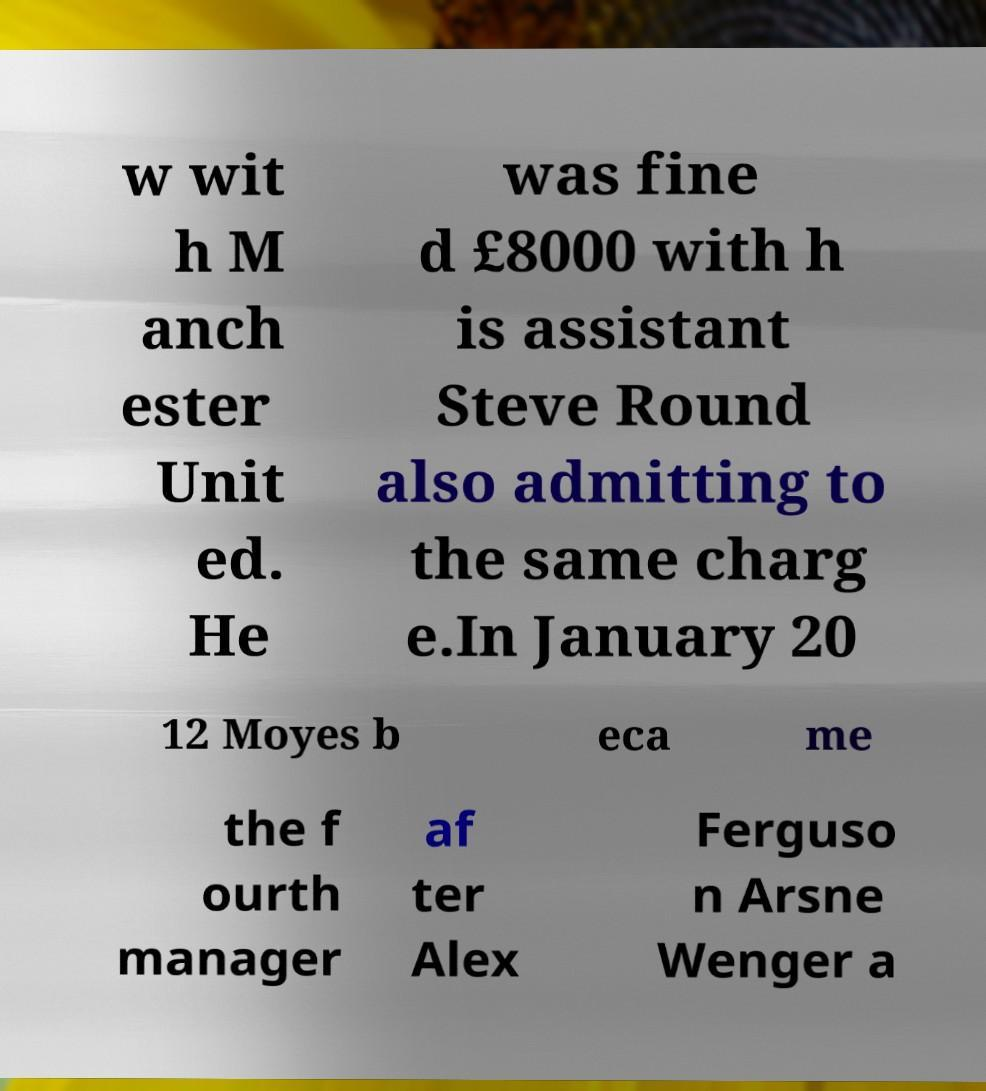Can you read and provide the text displayed in the image?This photo seems to have some interesting text. Can you extract and type it out for me? w wit h M anch ester Unit ed. He was fine d £8000 with h is assistant Steve Round also admitting to the same charg e.In January 20 12 Moyes b eca me the f ourth manager af ter Alex Ferguso n Arsne Wenger a 